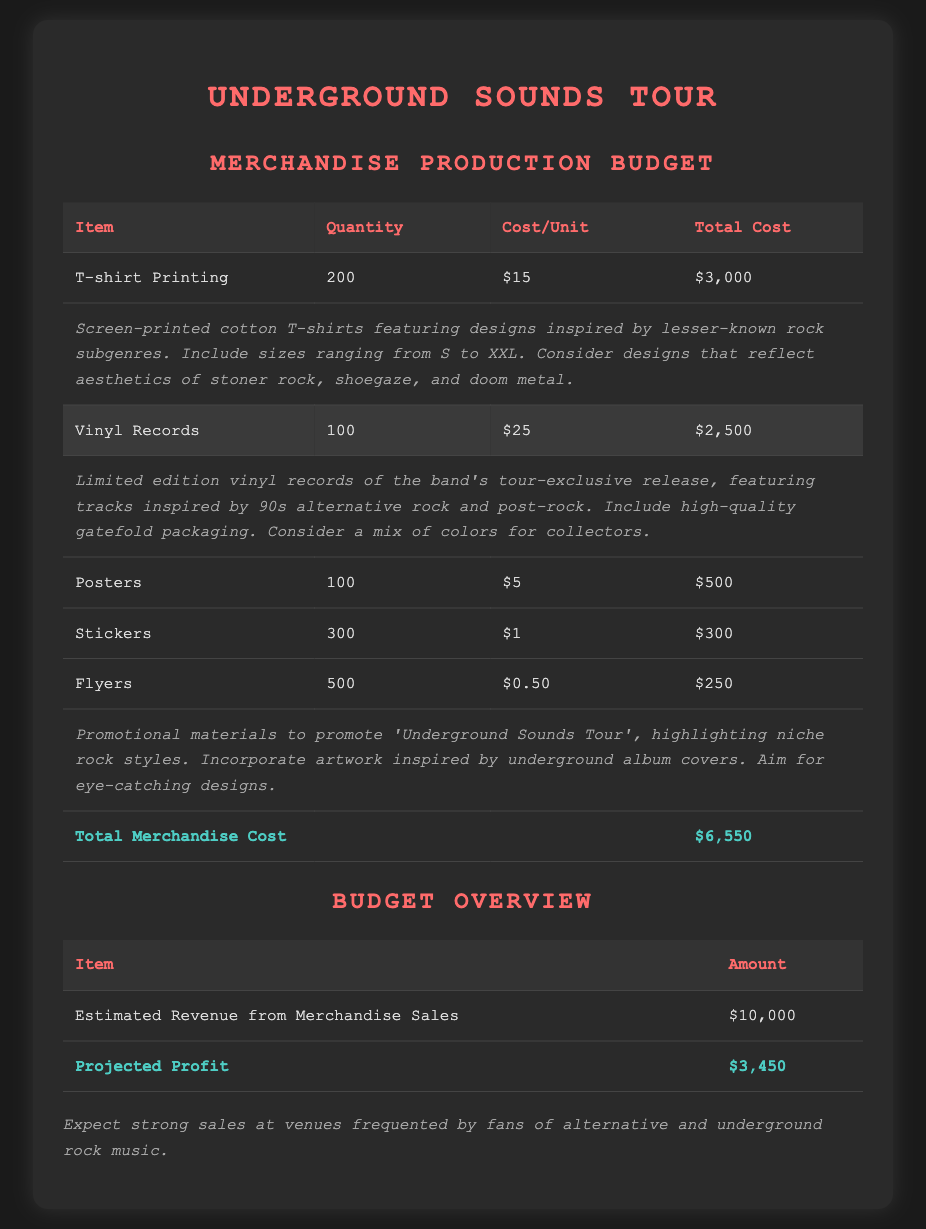What is the total cost for T-shirt printing? The total cost for T-shirt printing is specified in the budget as $3,000.
Answer: $3,000 How many vinyl records are included in the budget? The budget states that the quantity of vinyl records is 100.
Answer: 100 What is the cost per unit for stickers? The document indicates that the cost per unit for stickers is $1.
Answer: $1 What is the total merchandise cost? The total merchandise cost is detailed as $6,550 in the document.
Answer: $6,550 What type of packaging is used for the vinyl records? The budget notes that the vinyl records will include high-quality gatefold packaging.
Answer: Gatefold packaging How many flyers are included in the budget? The budget lists the quantity of flyers as 500.
Answer: 500 What is the estimated revenue from merchandise sales? The estimated revenue from merchandise sales is stated as $10,000 in the budget.
Answer: $10,000 What is the projected profit for the tour? The document specifies the projected profit as $3,450.
Answer: $3,450 What designs are featured on the T-shirts? The document mentions that the T-shirts feature designs inspired by lesser-known rock subgenres.
Answer: Lesser-known rock subgenres 